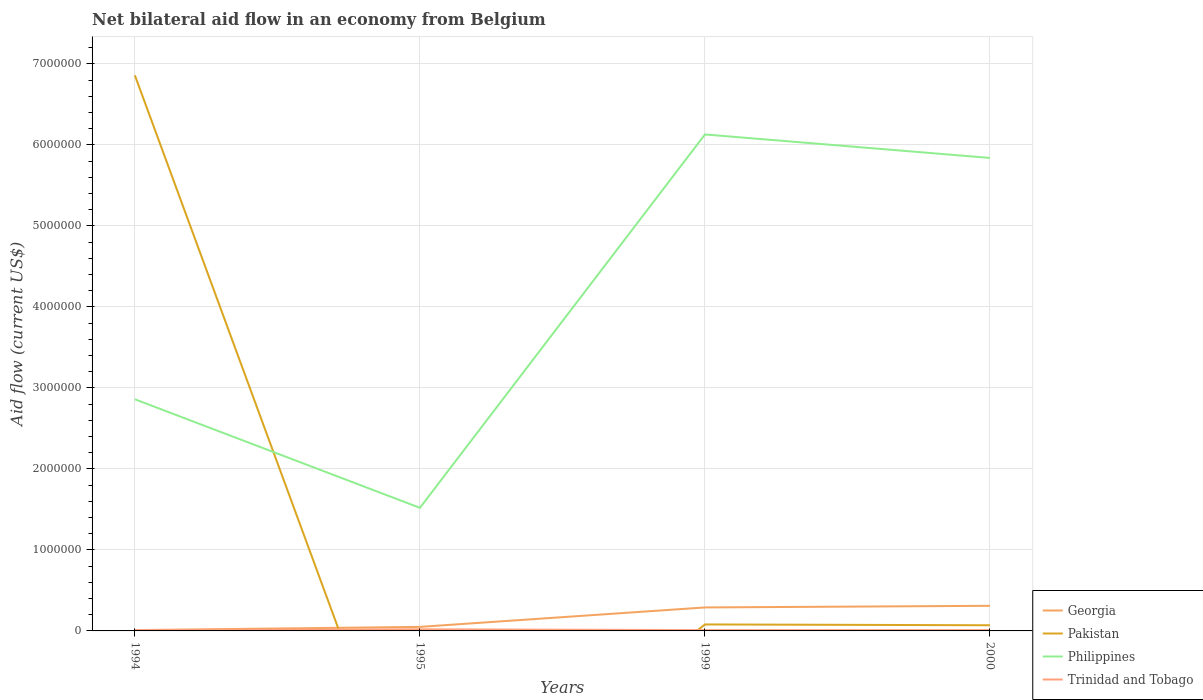How many different coloured lines are there?
Your response must be concise. 4. Does the line corresponding to Pakistan intersect with the line corresponding to Georgia?
Provide a succinct answer. Yes. Across all years, what is the maximum net bilateral aid flow in Georgia?
Give a very brief answer. 10000. What is the difference between the highest and the second highest net bilateral aid flow in Philippines?
Provide a succinct answer. 4.61e+06. How many lines are there?
Ensure brevity in your answer.  4. How many years are there in the graph?
Offer a very short reply. 4. Does the graph contain any zero values?
Your answer should be compact. Yes. Where does the legend appear in the graph?
Offer a very short reply. Bottom right. How are the legend labels stacked?
Your answer should be compact. Vertical. What is the title of the graph?
Offer a terse response. Net bilateral aid flow in an economy from Belgium. Does "Russian Federation" appear as one of the legend labels in the graph?
Give a very brief answer. No. What is the Aid flow (current US$) in Georgia in 1994?
Make the answer very short. 10000. What is the Aid flow (current US$) in Pakistan in 1994?
Provide a short and direct response. 6.86e+06. What is the Aid flow (current US$) in Philippines in 1994?
Give a very brief answer. 2.86e+06. What is the Aid flow (current US$) in Trinidad and Tobago in 1994?
Your answer should be compact. 10000. What is the Aid flow (current US$) of Pakistan in 1995?
Make the answer very short. 0. What is the Aid flow (current US$) in Philippines in 1995?
Make the answer very short. 1.52e+06. What is the Aid flow (current US$) of Trinidad and Tobago in 1995?
Provide a succinct answer. 2.00e+04. What is the Aid flow (current US$) of Philippines in 1999?
Keep it short and to the point. 6.13e+06. What is the Aid flow (current US$) in Georgia in 2000?
Your answer should be very brief. 3.10e+05. What is the Aid flow (current US$) in Philippines in 2000?
Provide a short and direct response. 5.84e+06. Across all years, what is the maximum Aid flow (current US$) in Pakistan?
Make the answer very short. 6.86e+06. Across all years, what is the maximum Aid flow (current US$) in Philippines?
Ensure brevity in your answer.  6.13e+06. Across all years, what is the minimum Aid flow (current US$) of Georgia?
Provide a short and direct response. 10000. Across all years, what is the minimum Aid flow (current US$) of Philippines?
Ensure brevity in your answer.  1.52e+06. What is the total Aid flow (current US$) in Pakistan in the graph?
Ensure brevity in your answer.  7.01e+06. What is the total Aid flow (current US$) of Philippines in the graph?
Ensure brevity in your answer.  1.64e+07. What is the difference between the Aid flow (current US$) in Georgia in 1994 and that in 1995?
Provide a short and direct response. -4.00e+04. What is the difference between the Aid flow (current US$) in Philippines in 1994 and that in 1995?
Make the answer very short. 1.34e+06. What is the difference between the Aid flow (current US$) in Georgia in 1994 and that in 1999?
Your answer should be compact. -2.80e+05. What is the difference between the Aid flow (current US$) of Pakistan in 1994 and that in 1999?
Give a very brief answer. 6.78e+06. What is the difference between the Aid flow (current US$) of Philippines in 1994 and that in 1999?
Your response must be concise. -3.27e+06. What is the difference between the Aid flow (current US$) of Georgia in 1994 and that in 2000?
Your answer should be very brief. -3.00e+05. What is the difference between the Aid flow (current US$) of Pakistan in 1994 and that in 2000?
Make the answer very short. 6.79e+06. What is the difference between the Aid flow (current US$) in Philippines in 1994 and that in 2000?
Offer a very short reply. -2.98e+06. What is the difference between the Aid flow (current US$) of Georgia in 1995 and that in 1999?
Your answer should be very brief. -2.40e+05. What is the difference between the Aid flow (current US$) in Philippines in 1995 and that in 1999?
Your answer should be very brief. -4.61e+06. What is the difference between the Aid flow (current US$) of Philippines in 1995 and that in 2000?
Your answer should be very brief. -4.32e+06. What is the difference between the Aid flow (current US$) of Trinidad and Tobago in 1999 and that in 2000?
Give a very brief answer. 0. What is the difference between the Aid flow (current US$) of Georgia in 1994 and the Aid flow (current US$) of Philippines in 1995?
Your answer should be compact. -1.51e+06. What is the difference between the Aid flow (current US$) of Pakistan in 1994 and the Aid flow (current US$) of Philippines in 1995?
Provide a short and direct response. 5.34e+06. What is the difference between the Aid flow (current US$) in Pakistan in 1994 and the Aid flow (current US$) in Trinidad and Tobago in 1995?
Give a very brief answer. 6.84e+06. What is the difference between the Aid flow (current US$) in Philippines in 1994 and the Aid flow (current US$) in Trinidad and Tobago in 1995?
Your response must be concise. 2.84e+06. What is the difference between the Aid flow (current US$) in Georgia in 1994 and the Aid flow (current US$) in Pakistan in 1999?
Your answer should be compact. -7.00e+04. What is the difference between the Aid flow (current US$) in Georgia in 1994 and the Aid flow (current US$) in Philippines in 1999?
Your response must be concise. -6.12e+06. What is the difference between the Aid flow (current US$) of Pakistan in 1994 and the Aid flow (current US$) of Philippines in 1999?
Your answer should be very brief. 7.30e+05. What is the difference between the Aid flow (current US$) in Pakistan in 1994 and the Aid flow (current US$) in Trinidad and Tobago in 1999?
Provide a short and direct response. 6.85e+06. What is the difference between the Aid flow (current US$) in Philippines in 1994 and the Aid flow (current US$) in Trinidad and Tobago in 1999?
Provide a succinct answer. 2.85e+06. What is the difference between the Aid flow (current US$) in Georgia in 1994 and the Aid flow (current US$) in Pakistan in 2000?
Offer a very short reply. -6.00e+04. What is the difference between the Aid flow (current US$) in Georgia in 1994 and the Aid flow (current US$) in Philippines in 2000?
Give a very brief answer. -5.83e+06. What is the difference between the Aid flow (current US$) of Georgia in 1994 and the Aid flow (current US$) of Trinidad and Tobago in 2000?
Give a very brief answer. 0. What is the difference between the Aid flow (current US$) of Pakistan in 1994 and the Aid flow (current US$) of Philippines in 2000?
Offer a very short reply. 1.02e+06. What is the difference between the Aid flow (current US$) in Pakistan in 1994 and the Aid flow (current US$) in Trinidad and Tobago in 2000?
Keep it short and to the point. 6.85e+06. What is the difference between the Aid flow (current US$) in Philippines in 1994 and the Aid flow (current US$) in Trinidad and Tobago in 2000?
Your response must be concise. 2.85e+06. What is the difference between the Aid flow (current US$) in Georgia in 1995 and the Aid flow (current US$) in Philippines in 1999?
Provide a short and direct response. -6.08e+06. What is the difference between the Aid flow (current US$) in Georgia in 1995 and the Aid flow (current US$) in Trinidad and Tobago in 1999?
Your answer should be very brief. 4.00e+04. What is the difference between the Aid flow (current US$) of Philippines in 1995 and the Aid flow (current US$) of Trinidad and Tobago in 1999?
Give a very brief answer. 1.51e+06. What is the difference between the Aid flow (current US$) of Georgia in 1995 and the Aid flow (current US$) of Philippines in 2000?
Your response must be concise. -5.79e+06. What is the difference between the Aid flow (current US$) of Georgia in 1995 and the Aid flow (current US$) of Trinidad and Tobago in 2000?
Ensure brevity in your answer.  4.00e+04. What is the difference between the Aid flow (current US$) of Philippines in 1995 and the Aid flow (current US$) of Trinidad and Tobago in 2000?
Offer a terse response. 1.51e+06. What is the difference between the Aid flow (current US$) in Georgia in 1999 and the Aid flow (current US$) in Philippines in 2000?
Your answer should be very brief. -5.55e+06. What is the difference between the Aid flow (current US$) in Georgia in 1999 and the Aid flow (current US$) in Trinidad and Tobago in 2000?
Your answer should be compact. 2.80e+05. What is the difference between the Aid flow (current US$) of Pakistan in 1999 and the Aid flow (current US$) of Philippines in 2000?
Your answer should be compact. -5.76e+06. What is the difference between the Aid flow (current US$) in Pakistan in 1999 and the Aid flow (current US$) in Trinidad and Tobago in 2000?
Your answer should be very brief. 7.00e+04. What is the difference between the Aid flow (current US$) in Philippines in 1999 and the Aid flow (current US$) in Trinidad and Tobago in 2000?
Your answer should be very brief. 6.12e+06. What is the average Aid flow (current US$) of Georgia per year?
Give a very brief answer. 1.65e+05. What is the average Aid flow (current US$) in Pakistan per year?
Give a very brief answer. 1.75e+06. What is the average Aid flow (current US$) of Philippines per year?
Your answer should be compact. 4.09e+06. What is the average Aid flow (current US$) in Trinidad and Tobago per year?
Offer a very short reply. 1.25e+04. In the year 1994, what is the difference between the Aid flow (current US$) of Georgia and Aid flow (current US$) of Pakistan?
Make the answer very short. -6.85e+06. In the year 1994, what is the difference between the Aid flow (current US$) in Georgia and Aid flow (current US$) in Philippines?
Ensure brevity in your answer.  -2.85e+06. In the year 1994, what is the difference between the Aid flow (current US$) of Georgia and Aid flow (current US$) of Trinidad and Tobago?
Keep it short and to the point. 0. In the year 1994, what is the difference between the Aid flow (current US$) of Pakistan and Aid flow (current US$) of Philippines?
Your response must be concise. 4.00e+06. In the year 1994, what is the difference between the Aid flow (current US$) in Pakistan and Aid flow (current US$) in Trinidad and Tobago?
Keep it short and to the point. 6.85e+06. In the year 1994, what is the difference between the Aid flow (current US$) in Philippines and Aid flow (current US$) in Trinidad and Tobago?
Offer a terse response. 2.85e+06. In the year 1995, what is the difference between the Aid flow (current US$) in Georgia and Aid flow (current US$) in Philippines?
Provide a succinct answer. -1.47e+06. In the year 1995, what is the difference between the Aid flow (current US$) in Philippines and Aid flow (current US$) in Trinidad and Tobago?
Your answer should be compact. 1.50e+06. In the year 1999, what is the difference between the Aid flow (current US$) of Georgia and Aid flow (current US$) of Philippines?
Give a very brief answer. -5.84e+06. In the year 1999, what is the difference between the Aid flow (current US$) in Pakistan and Aid flow (current US$) in Philippines?
Provide a short and direct response. -6.05e+06. In the year 1999, what is the difference between the Aid flow (current US$) in Pakistan and Aid flow (current US$) in Trinidad and Tobago?
Your answer should be compact. 7.00e+04. In the year 1999, what is the difference between the Aid flow (current US$) in Philippines and Aid flow (current US$) in Trinidad and Tobago?
Make the answer very short. 6.12e+06. In the year 2000, what is the difference between the Aid flow (current US$) of Georgia and Aid flow (current US$) of Philippines?
Your answer should be compact. -5.53e+06. In the year 2000, what is the difference between the Aid flow (current US$) of Pakistan and Aid flow (current US$) of Philippines?
Your answer should be compact. -5.77e+06. In the year 2000, what is the difference between the Aid flow (current US$) of Philippines and Aid flow (current US$) of Trinidad and Tobago?
Provide a short and direct response. 5.83e+06. What is the ratio of the Aid flow (current US$) of Philippines in 1994 to that in 1995?
Make the answer very short. 1.88. What is the ratio of the Aid flow (current US$) in Georgia in 1994 to that in 1999?
Give a very brief answer. 0.03. What is the ratio of the Aid flow (current US$) of Pakistan in 1994 to that in 1999?
Provide a short and direct response. 85.75. What is the ratio of the Aid flow (current US$) in Philippines in 1994 to that in 1999?
Provide a succinct answer. 0.47. What is the ratio of the Aid flow (current US$) of Trinidad and Tobago in 1994 to that in 1999?
Provide a succinct answer. 1. What is the ratio of the Aid flow (current US$) in Georgia in 1994 to that in 2000?
Make the answer very short. 0.03. What is the ratio of the Aid flow (current US$) in Pakistan in 1994 to that in 2000?
Provide a short and direct response. 98. What is the ratio of the Aid flow (current US$) in Philippines in 1994 to that in 2000?
Offer a terse response. 0.49. What is the ratio of the Aid flow (current US$) in Georgia in 1995 to that in 1999?
Keep it short and to the point. 0.17. What is the ratio of the Aid flow (current US$) of Philippines in 1995 to that in 1999?
Your answer should be compact. 0.25. What is the ratio of the Aid flow (current US$) in Georgia in 1995 to that in 2000?
Your answer should be compact. 0.16. What is the ratio of the Aid flow (current US$) in Philippines in 1995 to that in 2000?
Offer a very short reply. 0.26. What is the ratio of the Aid flow (current US$) in Georgia in 1999 to that in 2000?
Keep it short and to the point. 0.94. What is the ratio of the Aid flow (current US$) of Philippines in 1999 to that in 2000?
Offer a terse response. 1.05. What is the ratio of the Aid flow (current US$) in Trinidad and Tobago in 1999 to that in 2000?
Your answer should be very brief. 1. What is the difference between the highest and the second highest Aid flow (current US$) in Pakistan?
Ensure brevity in your answer.  6.78e+06. What is the difference between the highest and the second highest Aid flow (current US$) of Philippines?
Provide a short and direct response. 2.90e+05. What is the difference between the highest and the lowest Aid flow (current US$) in Georgia?
Your response must be concise. 3.00e+05. What is the difference between the highest and the lowest Aid flow (current US$) of Pakistan?
Give a very brief answer. 6.86e+06. What is the difference between the highest and the lowest Aid flow (current US$) of Philippines?
Ensure brevity in your answer.  4.61e+06. What is the difference between the highest and the lowest Aid flow (current US$) in Trinidad and Tobago?
Make the answer very short. 10000. 